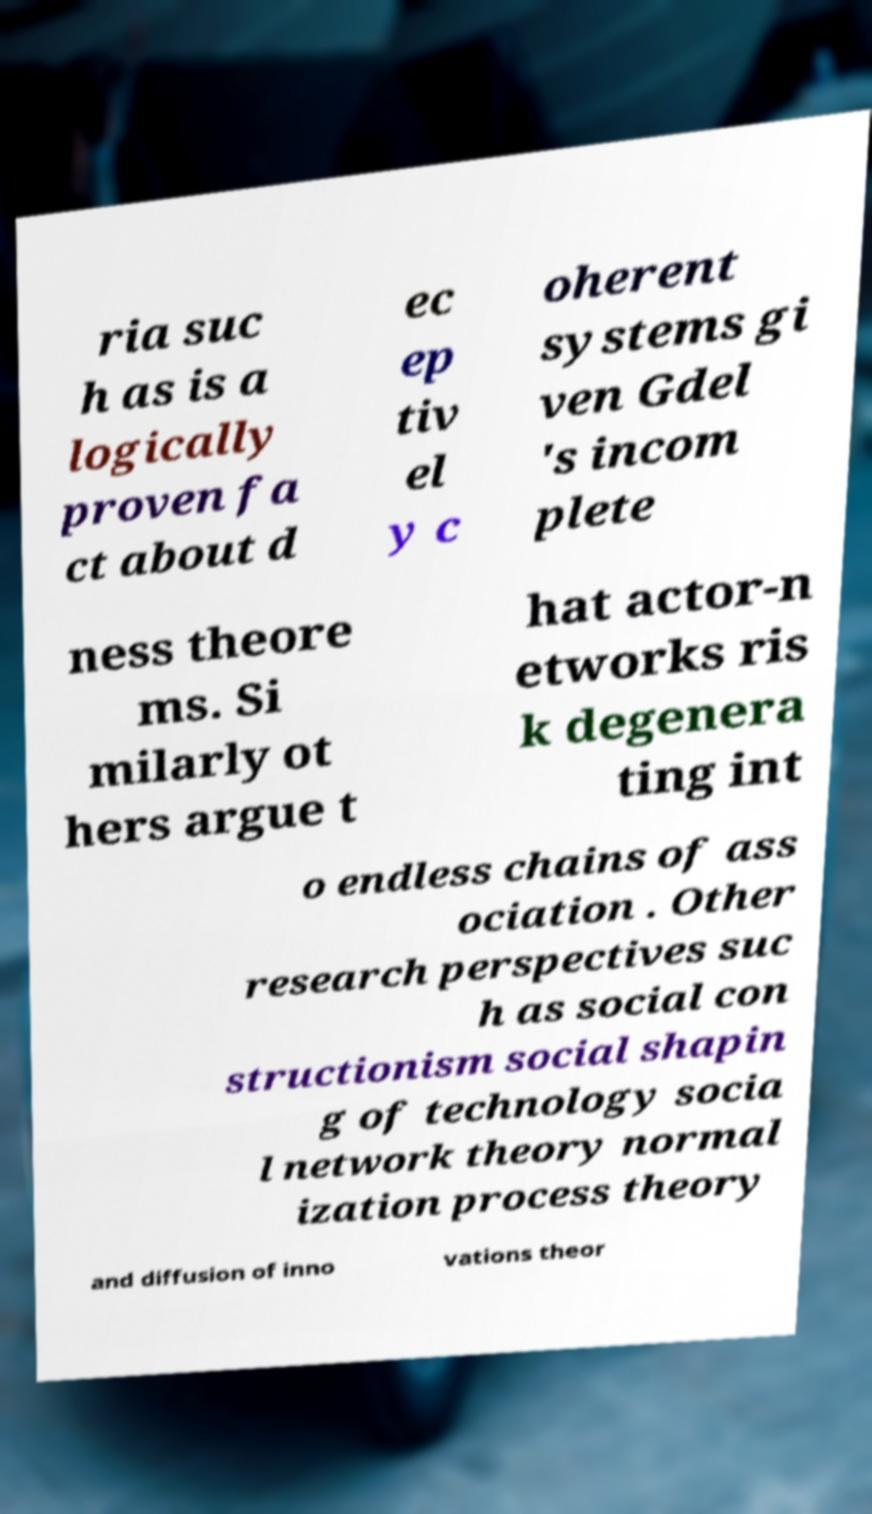Please read and relay the text visible in this image. What does it say? ria suc h as is a logically proven fa ct about d ec ep tiv el y c oherent systems gi ven Gdel 's incom plete ness theore ms. Si milarly ot hers argue t hat actor-n etworks ris k degenera ting int o endless chains of ass ociation . Other research perspectives suc h as social con structionism social shapin g of technology socia l network theory normal ization process theory and diffusion of inno vations theor 